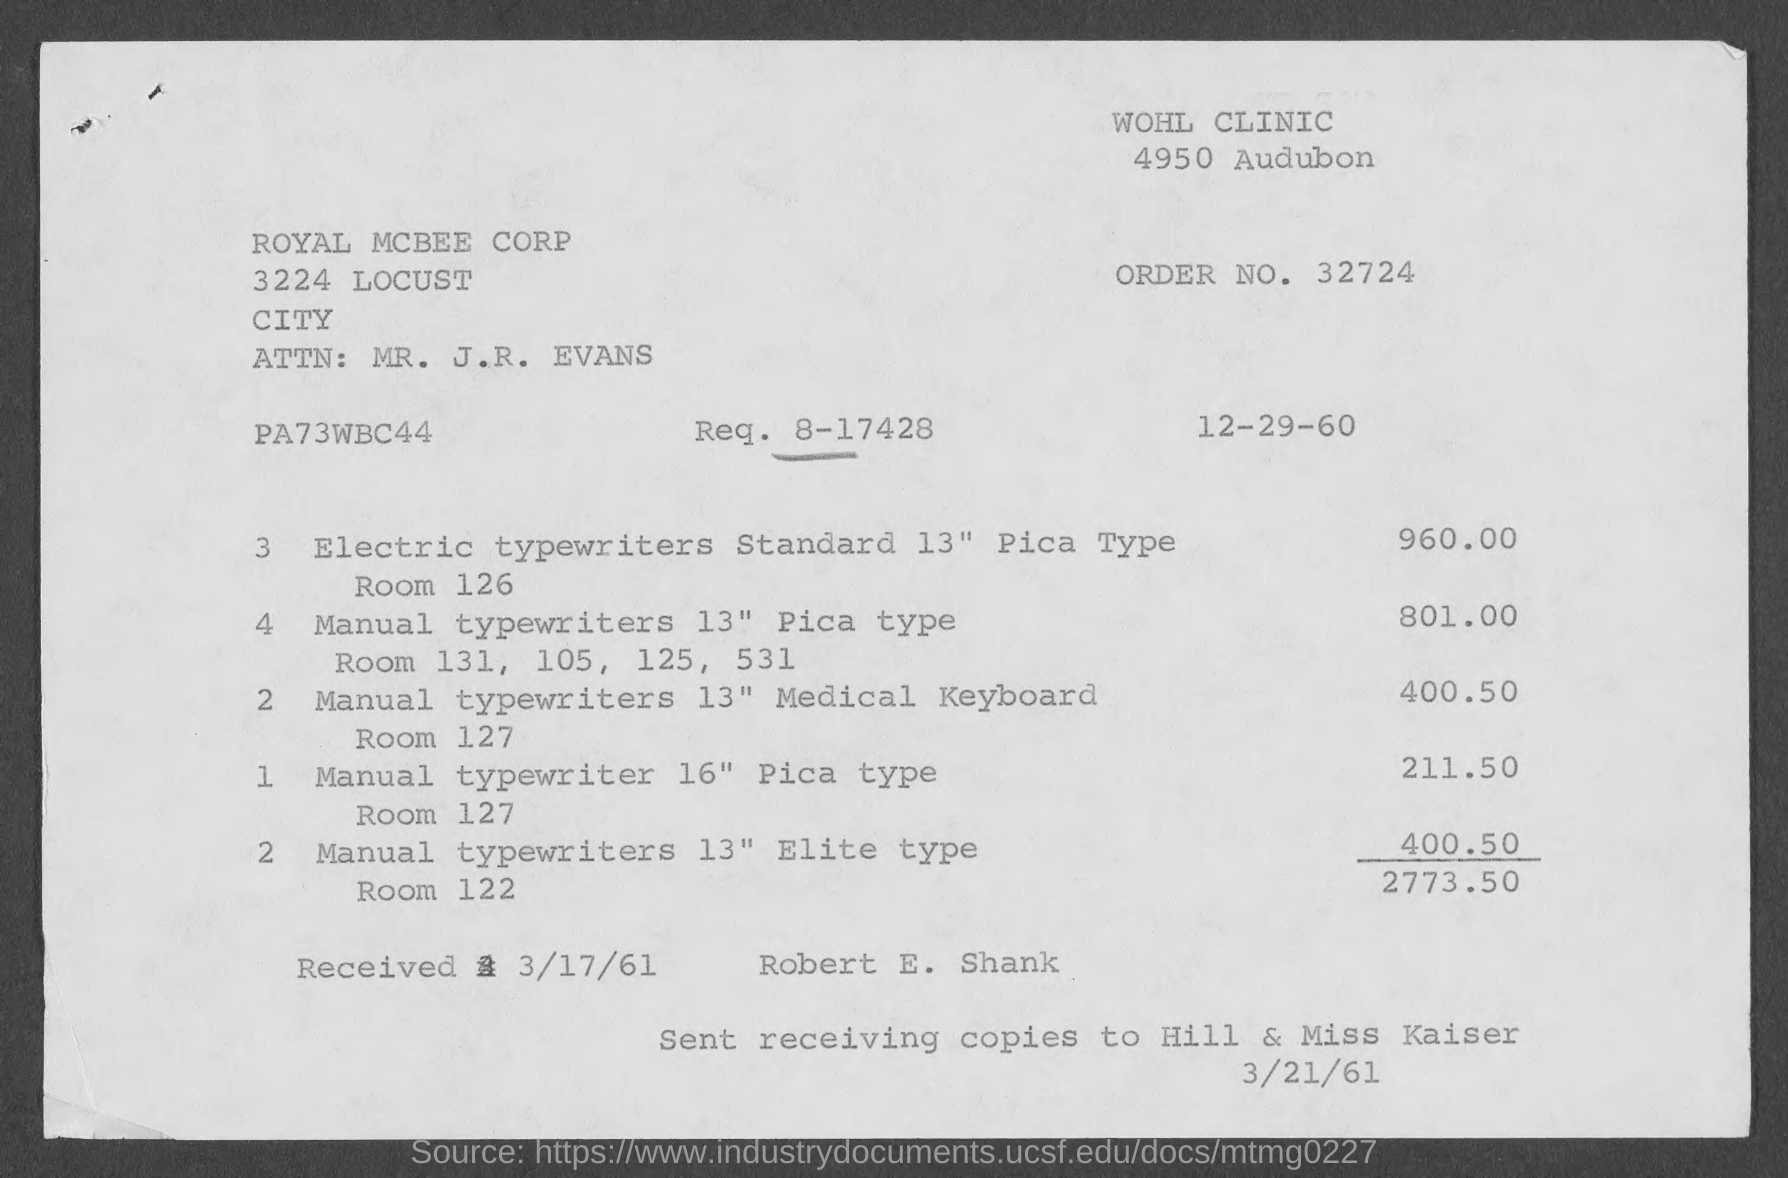What is the total cost of the manual typewriters listed on the invoice? The total cost of manual typewriters listed on the invoice is $2,175.00. This amount includes purchases from different rooms as specified in the document. 